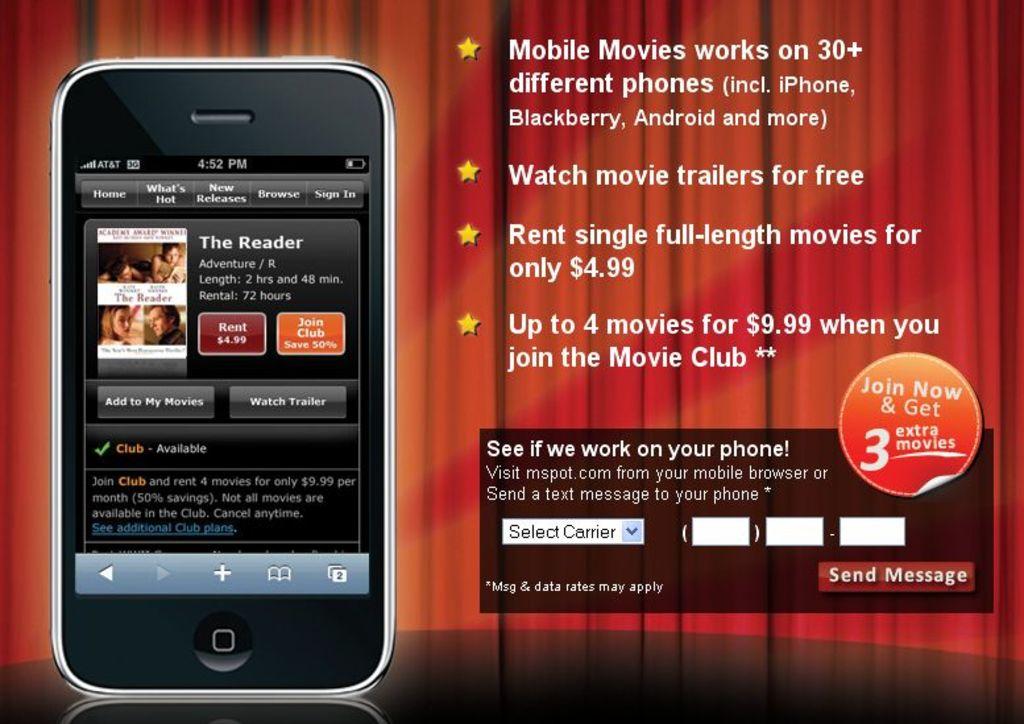How many phones does the mobile movies app work on?
Your answer should be compact. 30+. What does the last bullet point say?
Keep it short and to the point. Up to 4 movies for $9.99 when you join the movie club. 